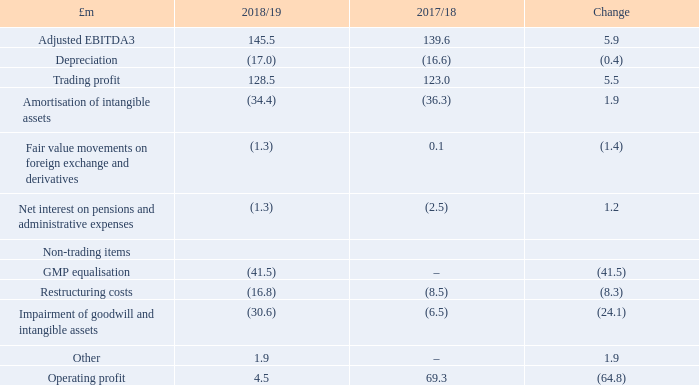The Group reports an operating profit of £4.5m for 2018/19, compared to £69.3m in the prior year. The growth in Trading profit of £5.5m in the year, as outlined above, was offset by an impairment of goodwill and intangible assets of £30.6m and costs of £41.5m relating to the recognition of Guaranteed Minimum Pension ('GMP') charges.
Amortisation of intangibles was £1.9m lower than 2017/18 due to certain SAP software modules becoming fully amortised in the year. Fair valuation of foreign exchange and derivatives was a charge of £1.3m in the year.
The Group recognised £41.5m of estimated costs in the year associated with the equalisation of GMP for pension benefits accrued between 1990 and 1997. This follows a judgement case of Lloyds Banking Group on 26 October 2018 which referred to the equal treatment of men and women who contracted out of the State Earnings Related Pension Scheme between these dates.
It should be noted that the final cost will differ to the estimated cost when the actual method of equalisation is agreed between the scheme Trustees in due course. Any future and final adjustment to the cost recognised in 2018/19 will be reflected in the Consolidated statement of comprehensive income. All UK companies who operated defined benefit pension schemes during these dates will be affected by this ruling.
Of this £41.5m non-cash charge, approximately two-thirds relates to the
RHM pension scheme and the balance relates to the Premier Foods pension schemes. Restructuring costs were £16.8m in the year; an £8.3m increase on the prior year and included circa £14m associated with the consolidation of the Group’s logistics operations to one central location in the year due to higher than anticipated implementation costs.
This programme has now completed and the Group does not expect to incur any further restructuring costs associated with this programme. Advisory fees associated with strategic reviews and corporate activity were also included in restructuring costs in the year. Other non-trading items of £1.9m refer to a past service pension credit of £3.9m due to inflation increases no longer required in a smaller Irish pension scheme, partly offset by costs related to the departure of previous CEO Gavin Darby.
Net interest on pensions and administrative expenses was a charge of £1.3m. Expenses for operating the Group’s pension schemes were £10.3m in the year, offset by a net interest credit of £9.0m due to an opening surplus of the Group’s combined pension schemes.
What was the operating profit in the year 2018/19 and 2017/18? £4.5m, £69.3m. What is the adjusted EBITDA in 2018/19?
Answer scale should be: million. 145.5. What led to Amortisation of intangibles being £1.9m lower than 2017/18? Due to certain sap software modules becoming fully amortised in the year. What is the change in Adjusted EBITDA from 2018/19 to 2017/18?
Answer scale should be: million. 145.5-139.6
Answer: 5.9. What is the change in Depreciation from 2018/19 to 2017/18?
Answer scale should be: million. 17.0-16.6
Answer: 0.4. What is the change in Trading profit from 2018/19 to 2017/18?
Answer scale should be: million. 128.5-123.0
Answer: 5.5. 